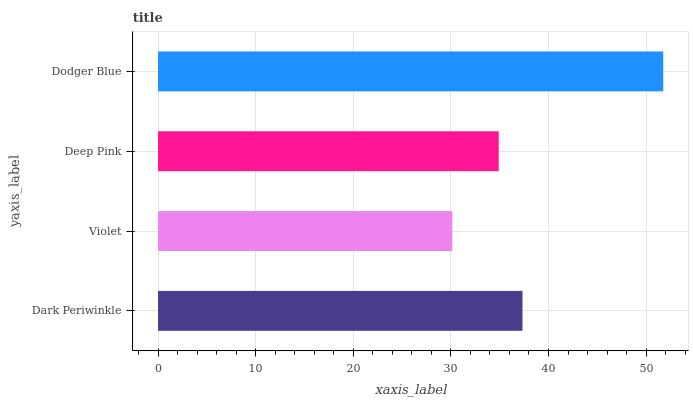Is Violet the minimum?
Answer yes or no. Yes. Is Dodger Blue the maximum?
Answer yes or no. Yes. Is Deep Pink the minimum?
Answer yes or no. No. Is Deep Pink the maximum?
Answer yes or no. No. Is Deep Pink greater than Violet?
Answer yes or no. Yes. Is Violet less than Deep Pink?
Answer yes or no. Yes. Is Violet greater than Deep Pink?
Answer yes or no. No. Is Deep Pink less than Violet?
Answer yes or no. No. Is Dark Periwinkle the high median?
Answer yes or no. Yes. Is Deep Pink the low median?
Answer yes or no. Yes. Is Deep Pink the high median?
Answer yes or no. No. Is Violet the low median?
Answer yes or no. No. 